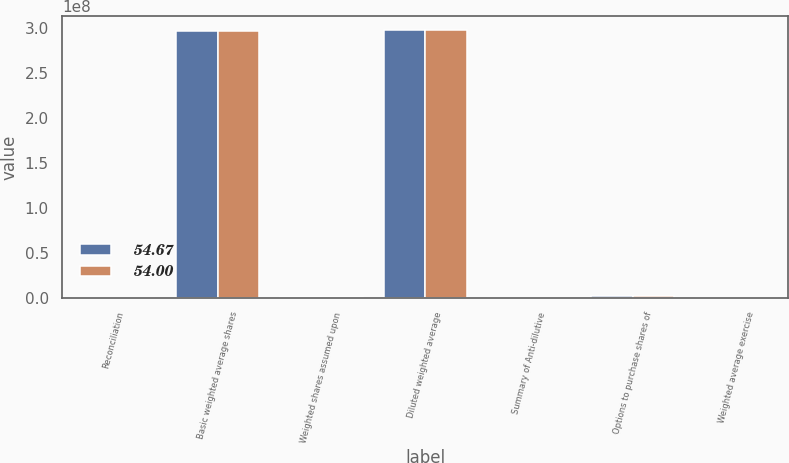<chart> <loc_0><loc_0><loc_500><loc_500><stacked_bar_chart><ecel><fcel>Reconciliation<fcel>Basic weighted average shares<fcel>Weighted shares assumed upon<fcel>Diluted weighted average<fcel>Summary of Anti-dilutive<fcel>Options to purchase shares of<fcel>Weighted average exercise<nl><fcel>54.67<fcel>2014<fcel>2.9649e+08<fcel>822866<fcel>2.97313e+08<fcel>2014<fcel>1.90377e+06<fcel>54.67<nl><fcel>54<fcel>2013<fcel>2.96754e+08<fcel>929428<fcel>2.97684e+08<fcel>2013<fcel>1.27353e+06<fcel>54<nl></chart> 